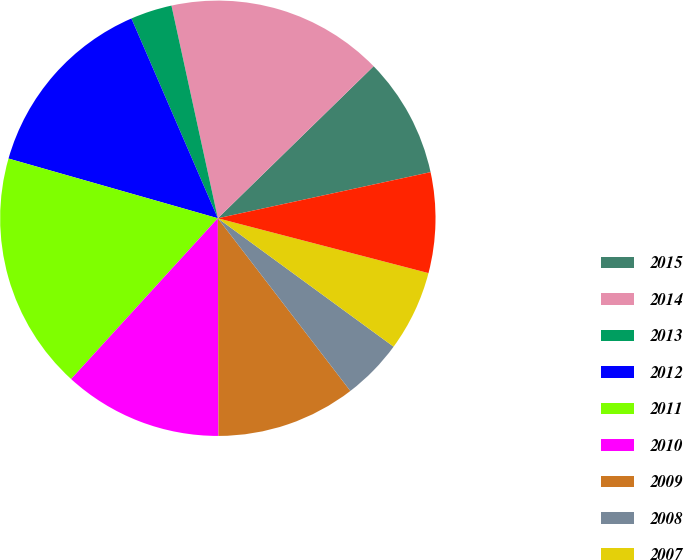Convert chart to OTSL. <chart><loc_0><loc_0><loc_500><loc_500><pie_chart><fcel>2015<fcel>2014<fcel>2013<fcel>2012<fcel>2011<fcel>2010<fcel>2009<fcel>2008<fcel>2007<fcel>2006<nl><fcel>8.91%<fcel>16.11%<fcel>3.08%<fcel>14.08%<fcel>17.65%<fcel>11.82%<fcel>10.37%<fcel>4.54%<fcel>5.99%<fcel>7.45%<nl></chart> 